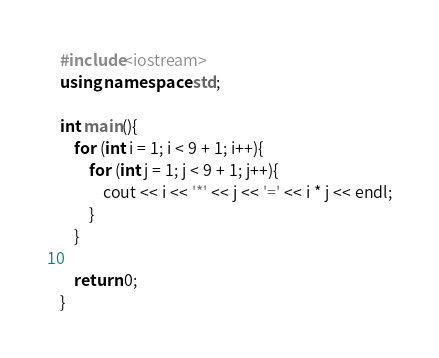<code> <loc_0><loc_0><loc_500><loc_500><_C++_>#include<iostream>
using namespace std;

int main(){
	for (int i = 1; i < 9 + 1; i++){
		for (int j = 1; j < 9 + 1; j++){
			cout << i << '*' << j << '=' << i * j << endl;
		}
	}

	return 0;
}
</code> 